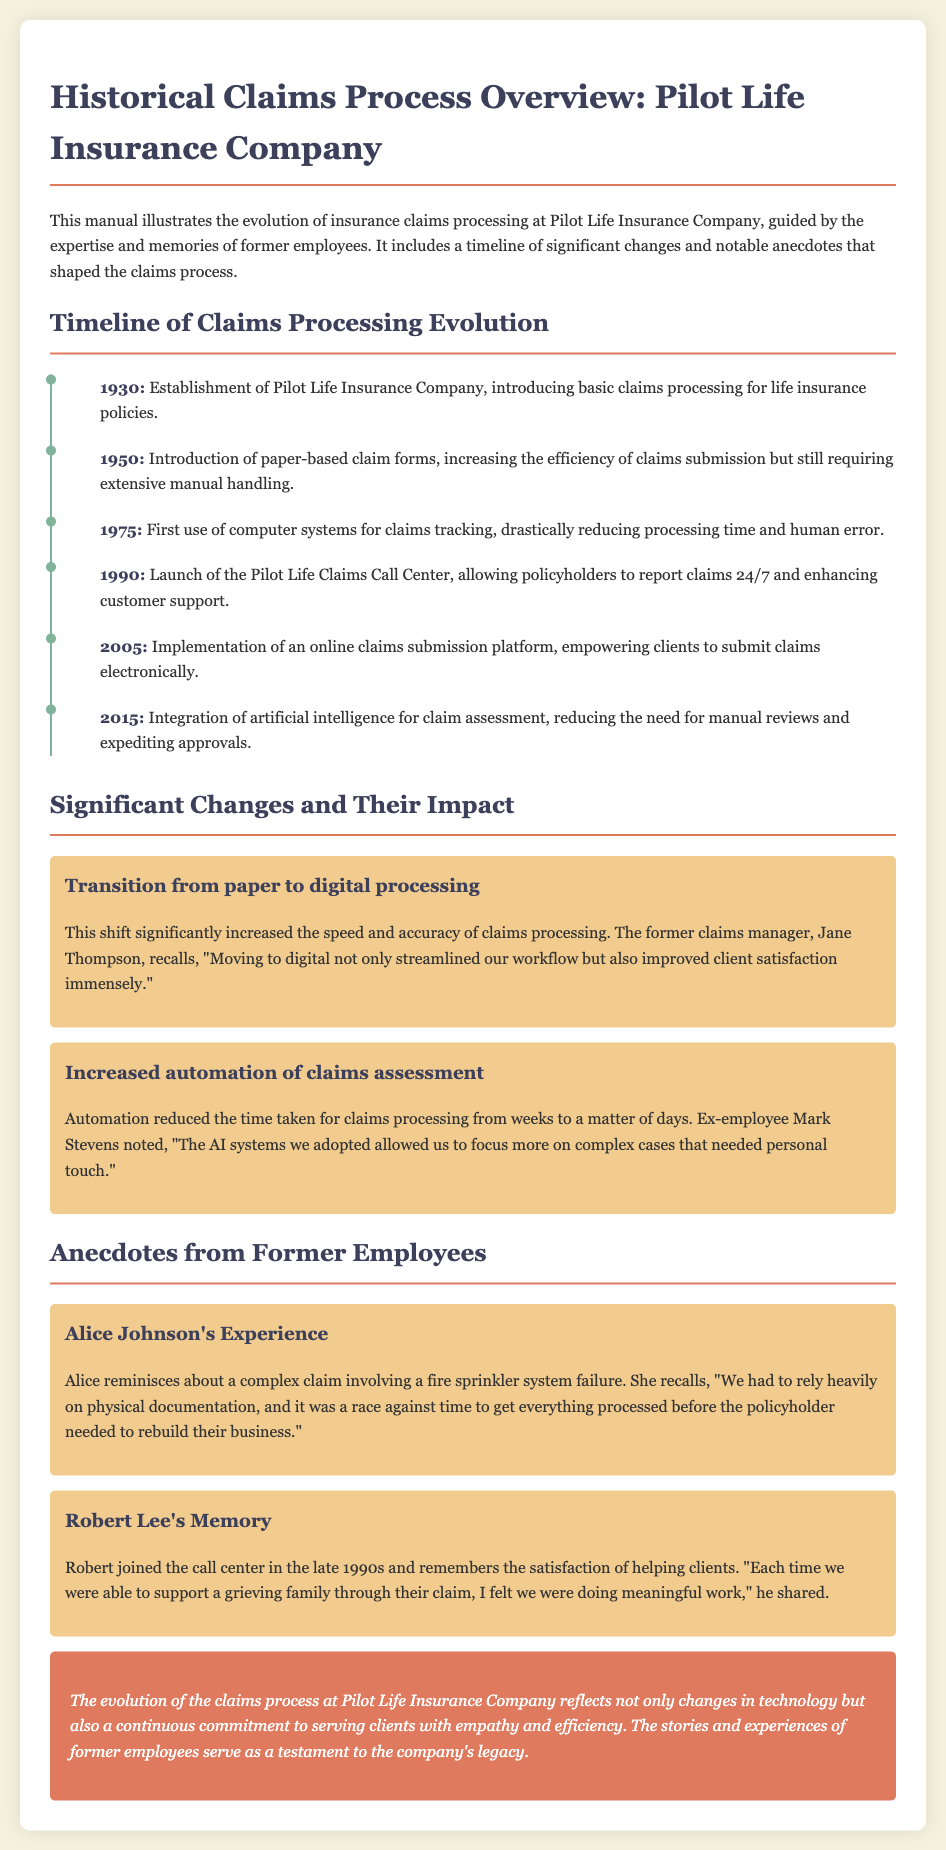What year was Pilot Life Insurance Company established? The document states that the establishment of Pilot Life Insurance Company occurred in 1930.
Answer: 1930 What significant change was introduced in 1990? The timeline indicates that in 1990, the Pilot Life Claims Call Center was launched.
Answer: The Pilot Life Claims Call Center Who was the former claims manager mentioned in the document? The document mentions Jane Thompson as the former claims manager during the transition to digital processing.
Answer: Jane Thompson What major transition occurred that improved client satisfaction? The document highlights the shift from paper to digital processing as significantly increasing client satisfaction.
Answer: Shift from paper to digital processing In which year was artificial intelligence integrated for claim assessment? According to the timeline, the integration of artificial intelligence for claim assessment took place in 2015.
Answer: 2015 What did Alice Johnson reminisce about? The document notes that Alice Johnson reminisced about a complex claim involving a fire sprinkler system failure.
Answer: A complex claim involving a fire sprinkler system failure What was the effect of increased automation on claims processing time? The document states that increased automation reduced processing time from weeks to a matter of days.
Answer: From weeks to a matter of days What type of document is this? The document is a manual illustrating the evolution of insurance claims processing at Pilot Life.
Answer: A manual What element of the claims process does Robert Lee mention feeling satisfaction about? Robert Lee mentions feeling satisfaction about helping clients through their claims.
Answer: Helping clients through their claims 